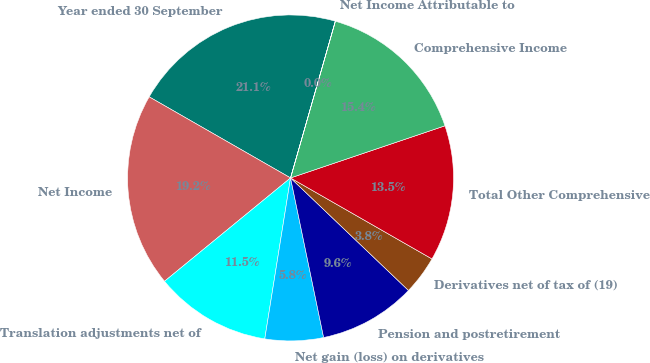<chart> <loc_0><loc_0><loc_500><loc_500><pie_chart><fcel>Year ended 30 September<fcel>Net Income<fcel>Translation adjustments net of<fcel>Net gain (loss) on derivatives<fcel>Pension and postretirement<fcel>Derivatives net of tax of (19)<fcel>Total Other Comprehensive<fcel>Comprehensive Income<fcel>Net Income Attributable to<nl><fcel>21.14%<fcel>19.22%<fcel>11.54%<fcel>5.78%<fcel>9.62%<fcel>3.85%<fcel>13.46%<fcel>15.38%<fcel>0.01%<nl></chart> 